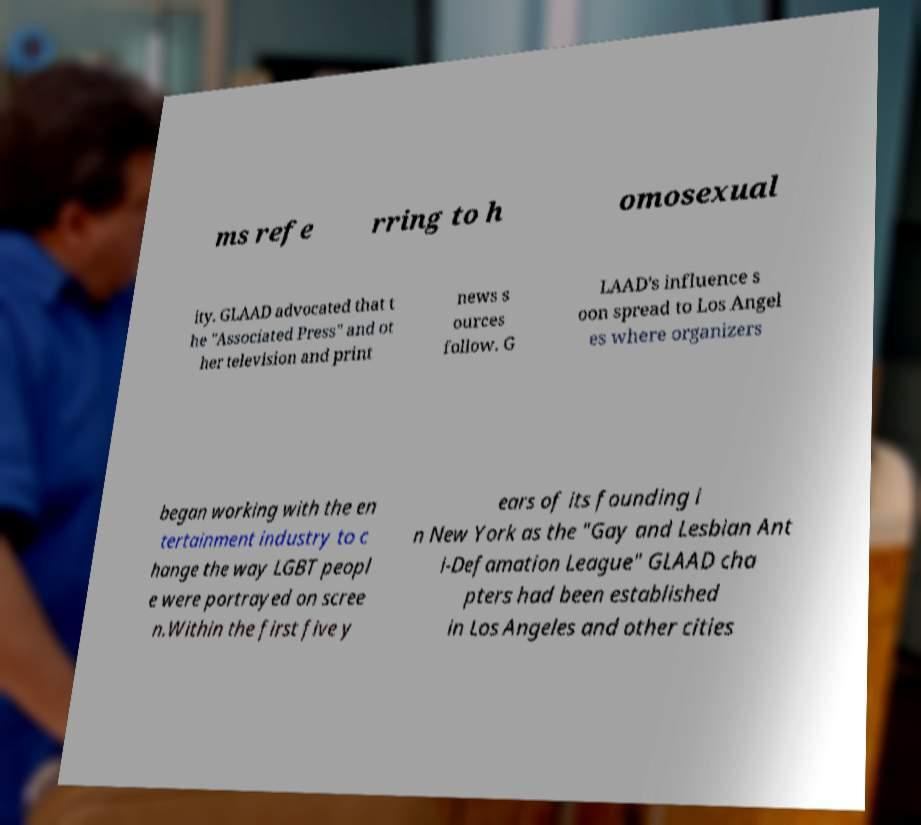Please identify and transcribe the text found in this image. ms refe rring to h omosexual ity. GLAAD advocated that t he "Associated Press" and ot her television and print news s ources follow. G LAAD's influence s oon spread to Los Angel es where organizers began working with the en tertainment industry to c hange the way LGBT peopl e were portrayed on scree n.Within the first five y ears of its founding i n New York as the "Gay and Lesbian Ant i-Defamation League" GLAAD cha pters had been established in Los Angeles and other cities 